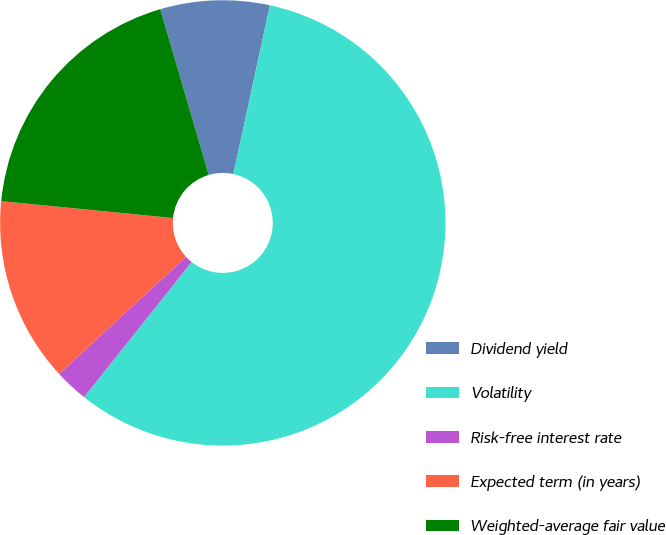Convert chart to OTSL. <chart><loc_0><loc_0><loc_500><loc_500><pie_chart><fcel>Dividend yield<fcel>Volatility<fcel>Risk-free interest rate<fcel>Expected term (in years)<fcel>Weighted-average fair value<nl><fcel>7.93%<fcel>57.31%<fcel>2.44%<fcel>13.42%<fcel>18.91%<nl></chart> 